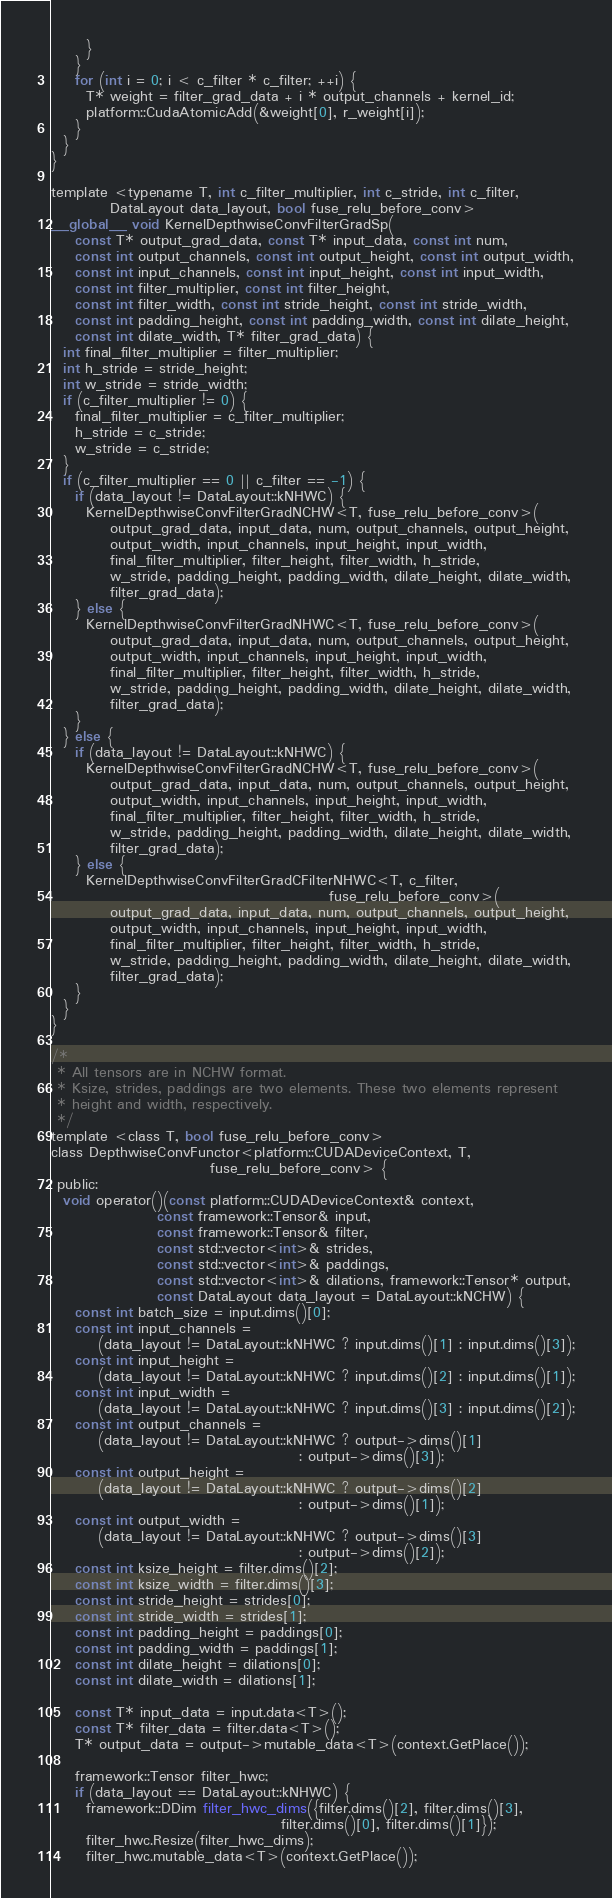Convert code to text. <code><loc_0><loc_0><loc_500><loc_500><_Cuda_>      }
    }
    for (int i = 0; i < c_filter * c_filter; ++i) {
      T* weight = filter_grad_data + i * output_channels + kernel_id;
      platform::CudaAtomicAdd(&weight[0], r_weight[i]);
    }
  }
}

template <typename T, int c_filter_multiplier, int c_stride, int c_filter,
          DataLayout data_layout, bool fuse_relu_before_conv>
__global__ void KernelDepthwiseConvFilterGradSp(
    const T* output_grad_data, const T* input_data, const int num,
    const int output_channels, const int output_height, const int output_width,
    const int input_channels, const int input_height, const int input_width,
    const int filter_multiplier, const int filter_height,
    const int filter_width, const int stride_height, const int stride_width,
    const int padding_height, const int padding_width, const int dilate_height,
    const int dilate_width, T* filter_grad_data) {
  int final_filter_multiplier = filter_multiplier;
  int h_stride = stride_height;
  int w_stride = stride_width;
  if (c_filter_multiplier != 0) {
    final_filter_multiplier = c_filter_multiplier;
    h_stride = c_stride;
    w_stride = c_stride;
  }
  if (c_filter_multiplier == 0 || c_filter == -1) {
    if (data_layout != DataLayout::kNHWC) {
      KernelDepthwiseConvFilterGradNCHW<T, fuse_relu_before_conv>(
          output_grad_data, input_data, num, output_channels, output_height,
          output_width, input_channels, input_height, input_width,
          final_filter_multiplier, filter_height, filter_width, h_stride,
          w_stride, padding_height, padding_width, dilate_height, dilate_width,
          filter_grad_data);
    } else {
      KernelDepthwiseConvFilterGradNHWC<T, fuse_relu_before_conv>(
          output_grad_data, input_data, num, output_channels, output_height,
          output_width, input_channels, input_height, input_width,
          final_filter_multiplier, filter_height, filter_width, h_stride,
          w_stride, padding_height, padding_width, dilate_height, dilate_width,
          filter_grad_data);
    }
  } else {
    if (data_layout != DataLayout::kNHWC) {
      KernelDepthwiseConvFilterGradNCHW<T, fuse_relu_before_conv>(
          output_grad_data, input_data, num, output_channels, output_height,
          output_width, input_channels, input_height, input_width,
          final_filter_multiplier, filter_height, filter_width, h_stride,
          w_stride, padding_height, padding_width, dilate_height, dilate_width,
          filter_grad_data);
    } else {
      KernelDepthwiseConvFilterGradCFilterNHWC<T, c_filter,
                                               fuse_relu_before_conv>(
          output_grad_data, input_data, num, output_channels, output_height,
          output_width, input_channels, input_height, input_width,
          final_filter_multiplier, filter_height, filter_width, h_stride,
          w_stride, padding_height, padding_width, dilate_height, dilate_width,
          filter_grad_data);
    }
  }
}

/*
 * All tensors are in NCHW format.
 * Ksize, strides, paddings are two elements. These two elements represent
 * height and width, respectively.
 */
template <class T, bool fuse_relu_before_conv>
class DepthwiseConvFunctor<platform::CUDADeviceContext, T,
                           fuse_relu_before_conv> {
 public:
  void operator()(const platform::CUDADeviceContext& context,
                  const framework::Tensor& input,
                  const framework::Tensor& filter,
                  const std::vector<int>& strides,
                  const std::vector<int>& paddings,
                  const std::vector<int>& dilations, framework::Tensor* output,
                  const DataLayout data_layout = DataLayout::kNCHW) {
    const int batch_size = input.dims()[0];
    const int input_channels =
        (data_layout != DataLayout::kNHWC ? input.dims()[1] : input.dims()[3]);
    const int input_height =
        (data_layout != DataLayout::kNHWC ? input.dims()[2] : input.dims()[1]);
    const int input_width =
        (data_layout != DataLayout::kNHWC ? input.dims()[3] : input.dims()[2]);
    const int output_channels =
        (data_layout != DataLayout::kNHWC ? output->dims()[1]
                                          : output->dims()[3]);
    const int output_height =
        (data_layout != DataLayout::kNHWC ? output->dims()[2]
                                          : output->dims()[1]);
    const int output_width =
        (data_layout != DataLayout::kNHWC ? output->dims()[3]
                                          : output->dims()[2]);
    const int ksize_height = filter.dims()[2];
    const int ksize_width = filter.dims()[3];
    const int stride_height = strides[0];
    const int stride_width = strides[1];
    const int padding_height = paddings[0];
    const int padding_width = paddings[1];
    const int dilate_height = dilations[0];
    const int dilate_width = dilations[1];

    const T* input_data = input.data<T>();
    const T* filter_data = filter.data<T>();
    T* output_data = output->mutable_data<T>(context.GetPlace());

    framework::Tensor filter_hwc;
    if (data_layout == DataLayout::kNHWC) {
      framework::DDim filter_hwc_dims({filter.dims()[2], filter.dims()[3],
                                       filter.dims()[0], filter.dims()[1]});
      filter_hwc.Resize(filter_hwc_dims);
      filter_hwc.mutable_data<T>(context.GetPlace());</code> 